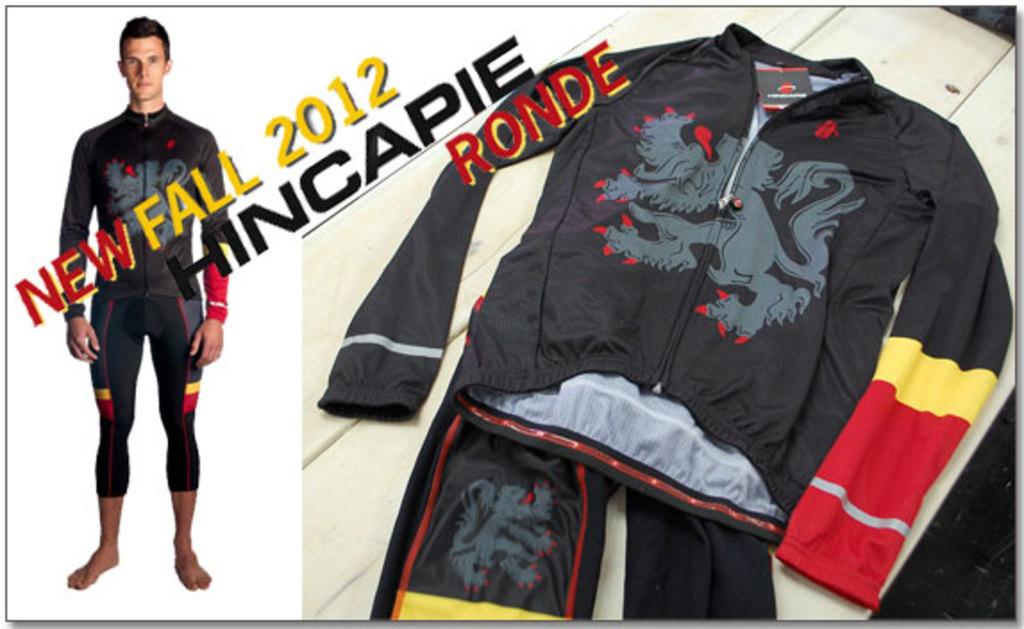When was this released?
Provide a succinct answer. 2012. Is this product new or old?
Your answer should be very brief. New. 